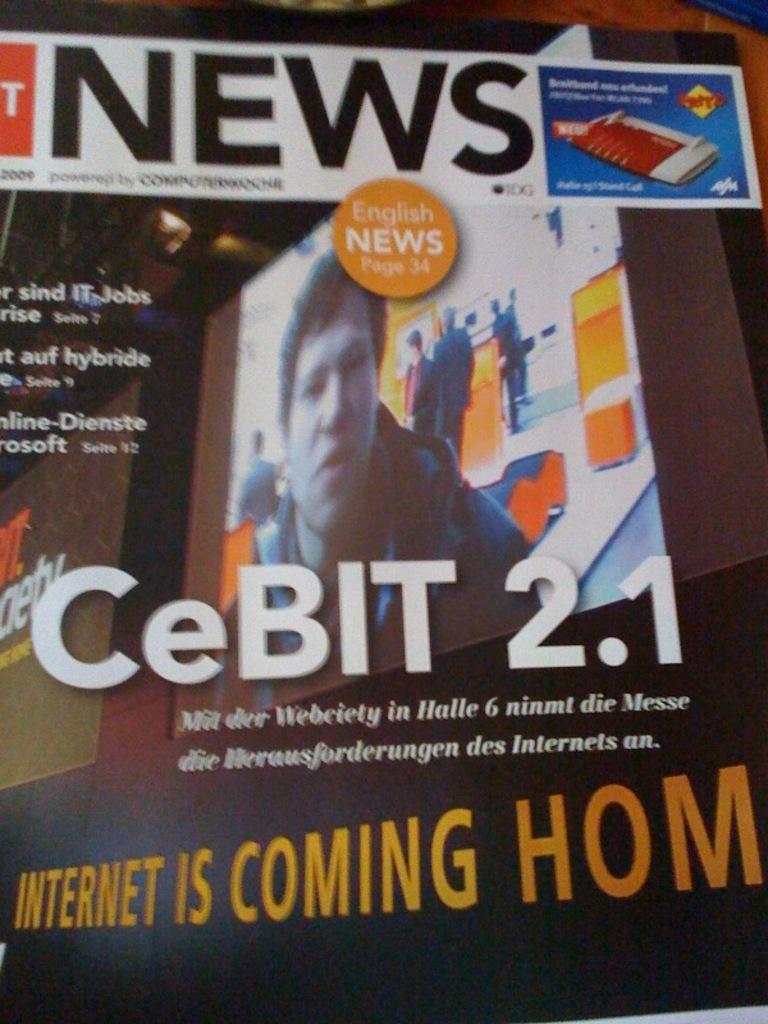What does the ad say is coming home?
Make the answer very short. Internet. What is this advertisement for?
Your answer should be compact. Cebit 2.1. 